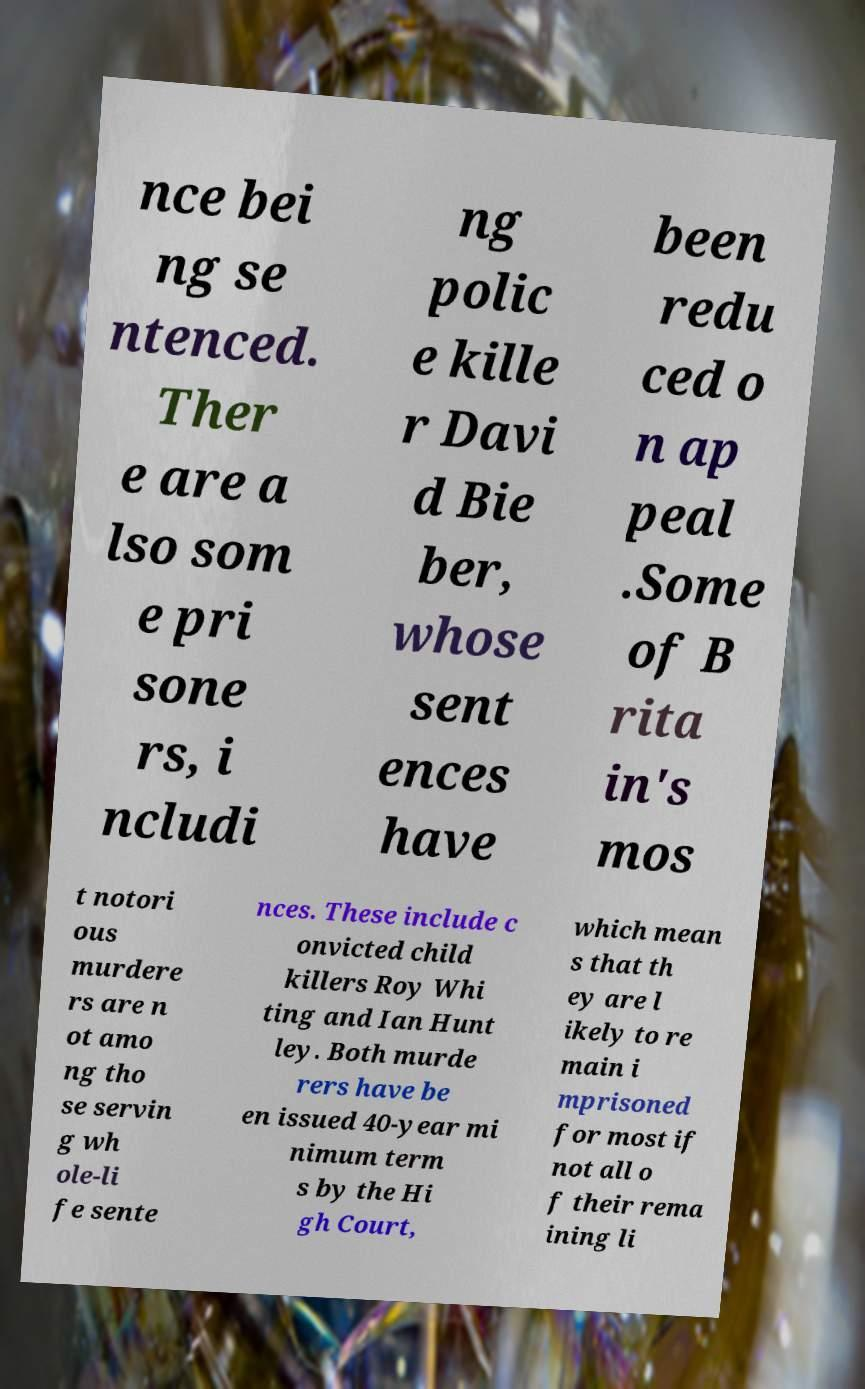What messages or text are displayed in this image? I need them in a readable, typed format. nce bei ng se ntenced. Ther e are a lso som e pri sone rs, i ncludi ng polic e kille r Davi d Bie ber, whose sent ences have been redu ced o n ap peal .Some of B rita in's mos t notori ous murdere rs are n ot amo ng tho se servin g wh ole-li fe sente nces. These include c onvicted child killers Roy Whi ting and Ian Hunt ley. Both murde rers have be en issued 40-year mi nimum term s by the Hi gh Court, which mean s that th ey are l ikely to re main i mprisoned for most if not all o f their rema ining li 